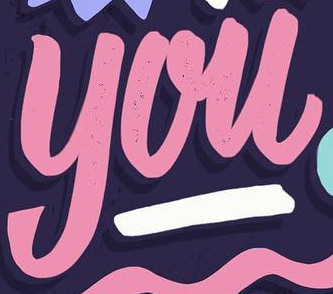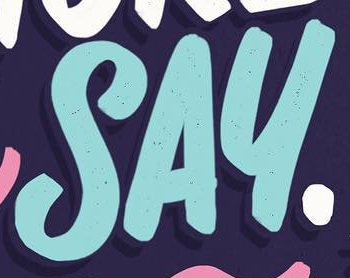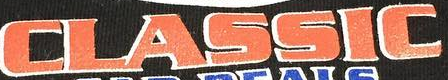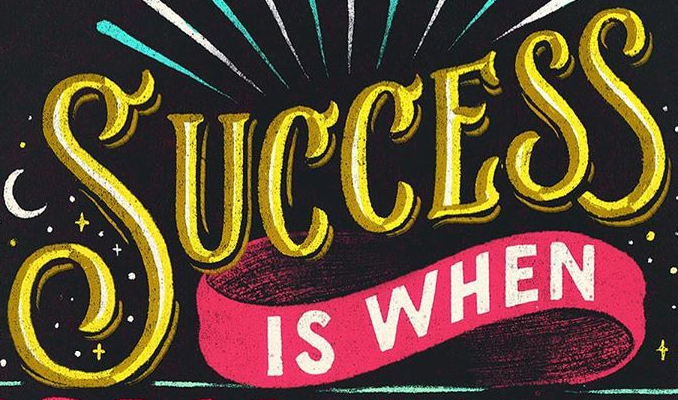What words are shown in these images in order, separated by a semicolon? you; SAY; CLASSIC; SUCCESS 